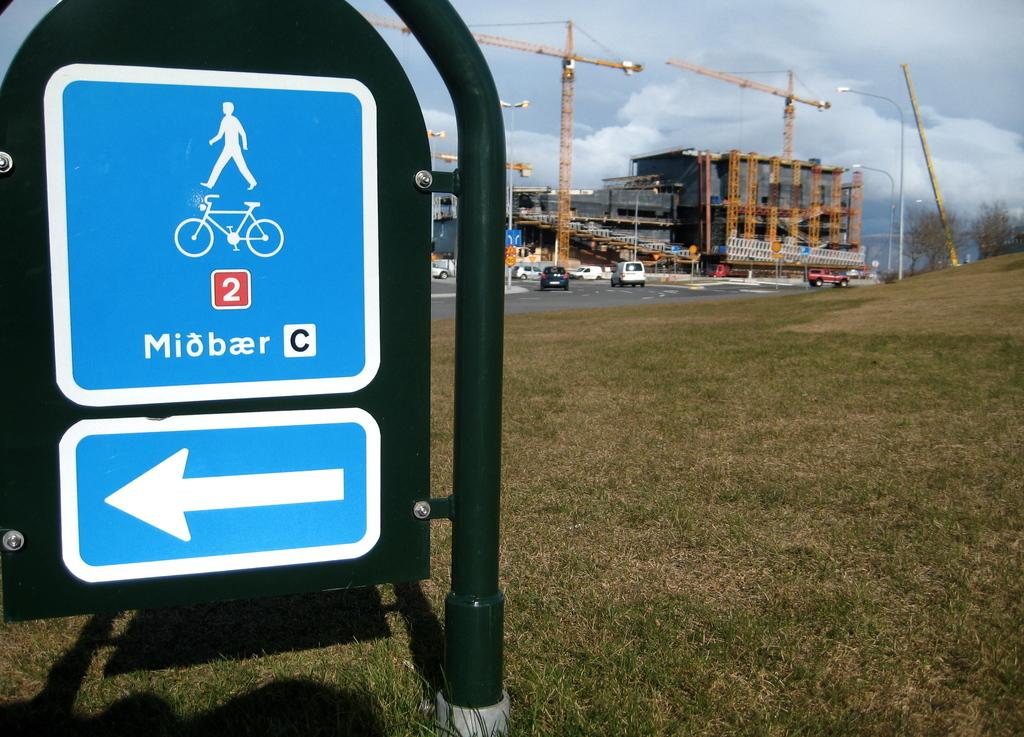Provide a one-sentence caption for the provided image. A blue and white sign that has a man on top and bicycle below. 